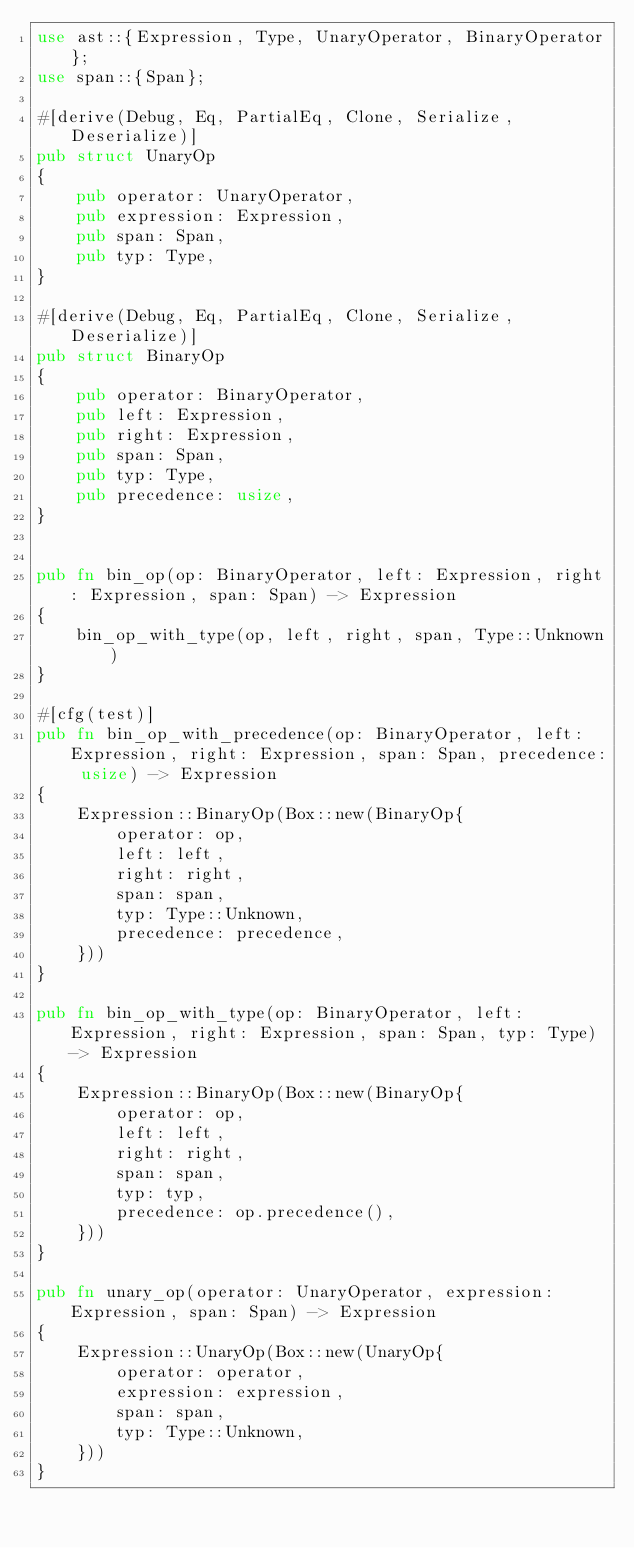<code> <loc_0><loc_0><loc_500><loc_500><_Rust_>use ast::{Expression, Type, UnaryOperator, BinaryOperator};
use span::{Span};

#[derive(Debug, Eq, PartialEq, Clone, Serialize, Deserialize)]
pub struct UnaryOp
{
    pub operator: UnaryOperator,
    pub expression: Expression,
    pub span: Span,
    pub typ: Type,
}

#[derive(Debug, Eq, PartialEq, Clone, Serialize, Deserialize)]
pub struct BinaryOp
{
    pub operator: BinaryOperator,
    pub left: Expression,
    pub right: Expression,
    pub span: Span,
    pub typ: Type,
    pub precedence: usize,
}


pub fn bin_op(op: BinaryOperator, left: Expression, right: Expression, span: Span) -> Expression
{
    bin_op_with_type(op, left, right, span, Type::Unknown)
}

#[cfg(test)]
pub fn bin_op_with_precedence(op: BinaryOperator, left: Expression, right: Expression, span: Span, precedence: usize) -> Expression
{
    Expression::BinaryOp(Box::new(BinaryOp{
        operator: op,
        left: left,
        right: right,
        span: span,
        typ: Type::Unknown,
        precedence: precedence,
    }))
}

pub fn bin_op_with_type(op: BinaryOperator, left: Expression, right: Expression, span: Span, typ: Type) -> Expression
{
    Expression::BinaryOp(Box::new(BinaryOp{
        operator: op,
        left: left,
        right: right,
        span: span,
        typ: typ,
        precedence: op.precedence(),
    }))
}

pub fn unary_op(operator: UnaryOperator, expression: Expression, span: Span) -> Expression
{
    Expression::UnaryOp(Box::new(UnaryOp{
        operator: operator,
        expression: expression,
        span: span,
        typ: Type::Unknown,
    }))
}
</code> 